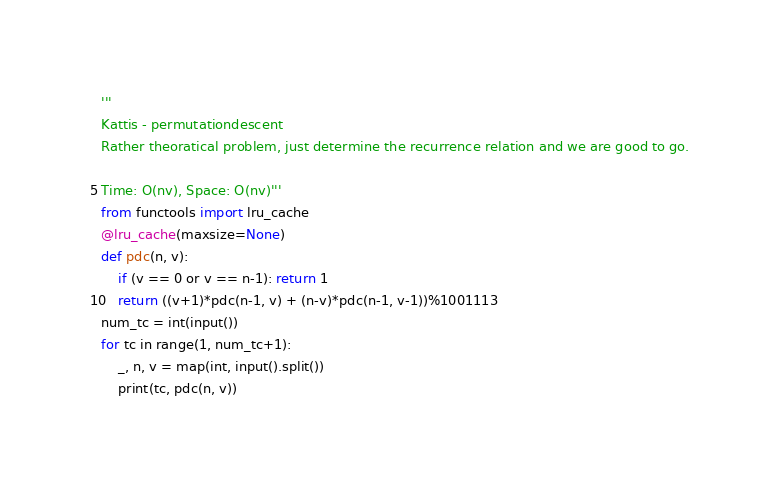Convert code to text. <code><loc_0><loc_0><loc_500><loc_500><_Python_>'''
Kattis - permutationdescent
Rather theoratical problem, just determine the recurrence relation and we are good to go.

Time: O(nv), Space: O(nv)'''
from functools import lru_cache
@lru_cache(maxsize=None)
def pdc(n, v):
    if (v == 0 or v == n-1): return 1
    return ((v+1)*pdc(n-1, v) + (n-v)*pdc(n-1, v-1))%1001113
num_tc = int(input())
for tc in range(1, num_tc+1):
    _, n, v = map(int, input().split())
    print(tc, pdc(n, v))</code> 